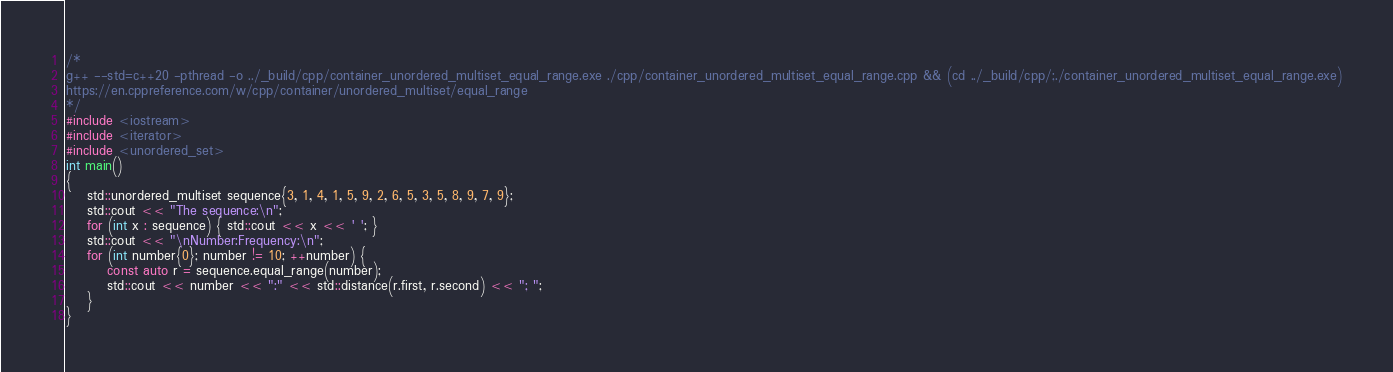<code> <loc_0><loc_0><loc_500><loc_500><_C++_>/*
g++ --std=c++20 -pthread -o ../_build/cpp/container_unordered_multiset_equal_range.exe ./cpp/container_unordered_multiset_equal_range.cpp && (cd ../_build/cpp/;./container_unordered_multiset_equal_range.exe)
https://en.cppreference.com/w/cpp/container/unordered_multiset/equal_range
*/
#include <iostream>
#include <iterator>
#include <unordered_set>
int main()
{
    std::unordered_multiset sequence{3, 1, 4, 1, 5, 9, 2, 6, 5, 3, 5, 8, 9, 7, 9};
    std::cout << "The sequence:\n";
    for (int x : sequence) { std::cout << x << ' '; }
    std::cout << "\nNumber:Frequency:\n";
    for (int number{0}; number != 10; ++number) {
        const auto r = sequence.equal_range(number);
        std::cout << number << ":" << std::distance(r.first, r.second) << "; ";
    }
}

</code> 